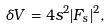<formula> <loc_0><loc_0><loc_500><loc_500>\delta V = 4 s ^ { 2 } | F _ { s } | ^ { 2 } ,</formula> 